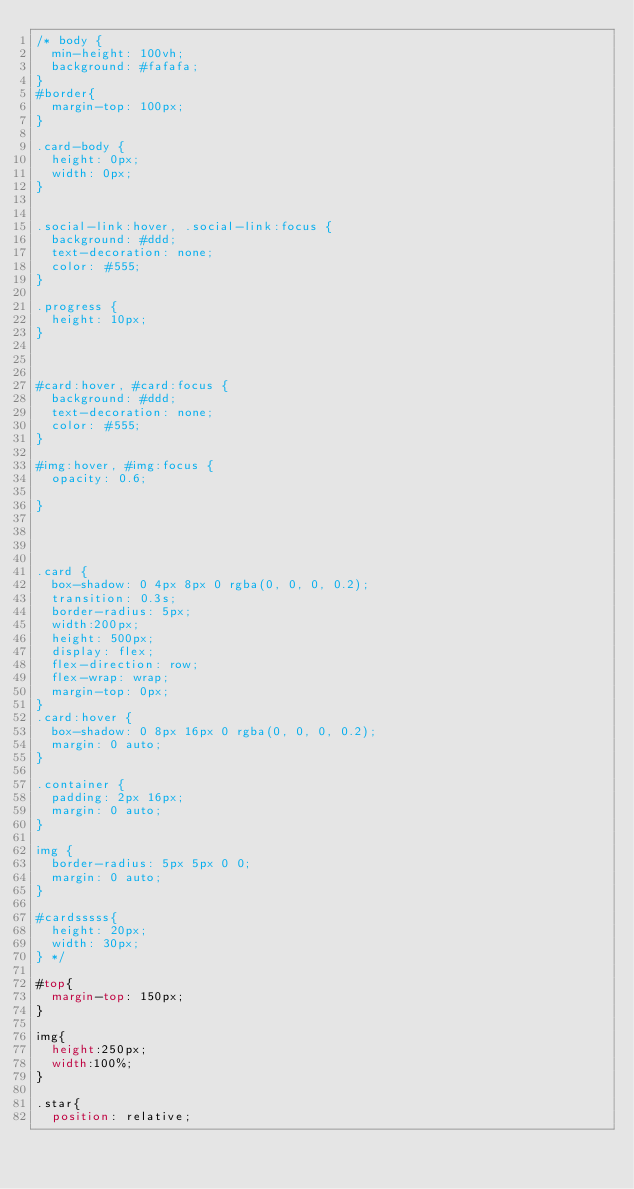Convert code to text. <code><loc_0><loc_0><loc_500><loc_500><_CSS_>/* body {
  min-height: 100vh;
  background: #fafafa;
}
#border{
  margin-top: 100px;
}

.card-body {
  height: 0px;
  width: 0px;
}


.social-link:hover, .social-link:focus {
  background: #ddd;
  text-decoration: none;
  color: #555;
}

.progress {
  height: 10px;
}



#card:hover, #card:focus {
  background: #ddd;
  text-decoration: none;
  color: #555;
}

#img:hover, #img:focus {
  opacity: 0.6;

}




.card {
  box-shadow: 0 4px 8px 0 rgba(0, 0, 0, 0.2);
  transition: 0.3s;
  border-radius: 5px;
  width:200px;
  height: 500px;
  display: flex;
  flex-direction: row;
  flex-wrap: wrap;
  margin-top: 0px;
}
.card:hover {
  box-shadow: 0 8px 16px 0 rgba(0, 0, 0, 0.2);
  margin: 0 auto;
}

.container {
  padding: 2px 16px;
  margin: 0 auto;
}

img {
  border-radius: 5px 5px 0 0;
  margin: 0 auto;
} 

#cardsssss{
  height: 20px;
  width: 30px;
} */

#top{
  margin-top: 150px;
}

img{
  height:250px;
  width:100%;
}

.star{
  position: relative;</code> 